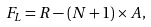<formula> <loc_0><loc_0><loc_500><loc_500>F _ { L } = R - ( N + 1 ) \times A ,</formula> 